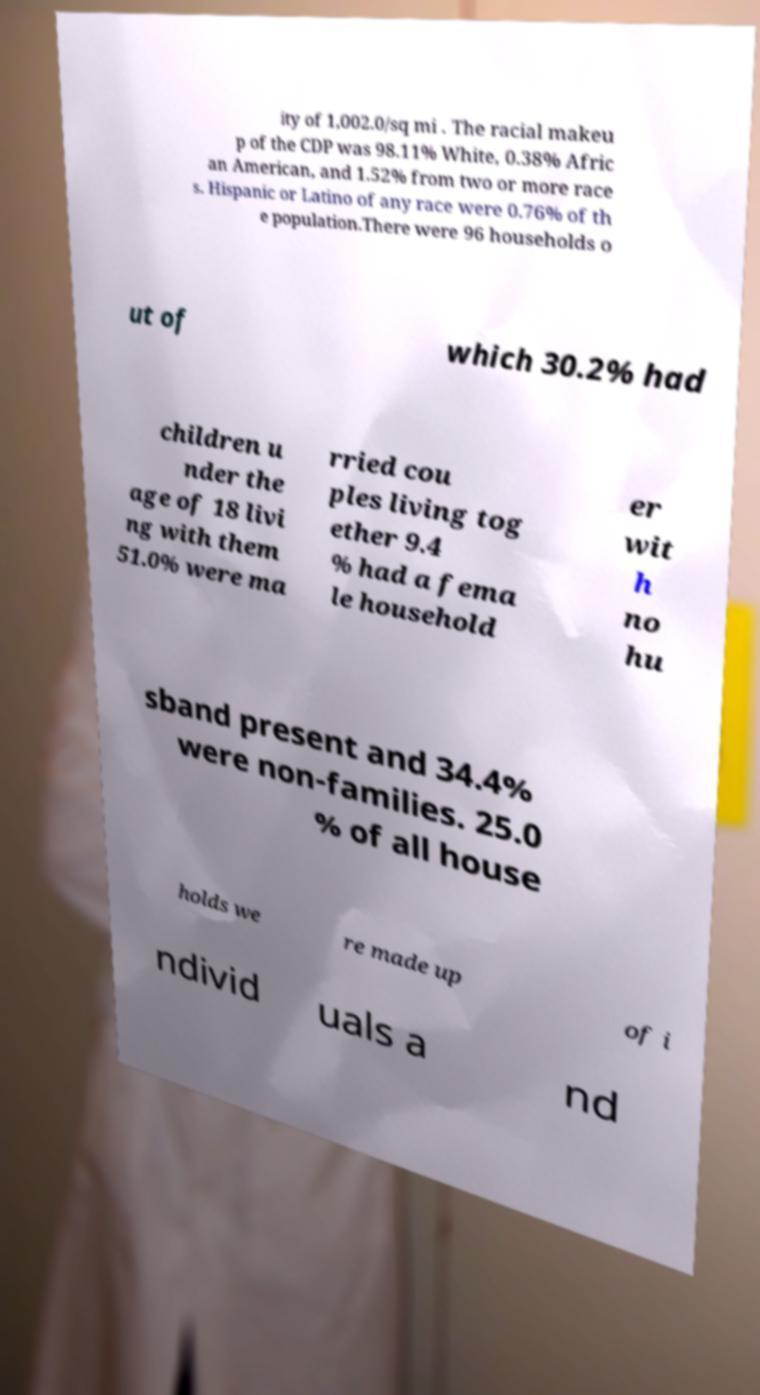There's text embedded in this image that I need extracted. Can you transcribe it verbatim? ity of 1,002.0/sq mi . The racial makeu p of the CDP was 98.11% White, 0.38% Afric an American, and 1.52% from two or more race s. Hispanic or Latino of any race were 0.76% of th e population.There were 96 households o ut of which 30.2% had children u nder the age of 18 livi ng with them 51.0% were ma rried cou ples living tog ether 9.4 % had a fema le household er wit h no hu sband present and 34.4% were non-families. 25.0 % of all house holds we re made up of i ndivid uals a nd 